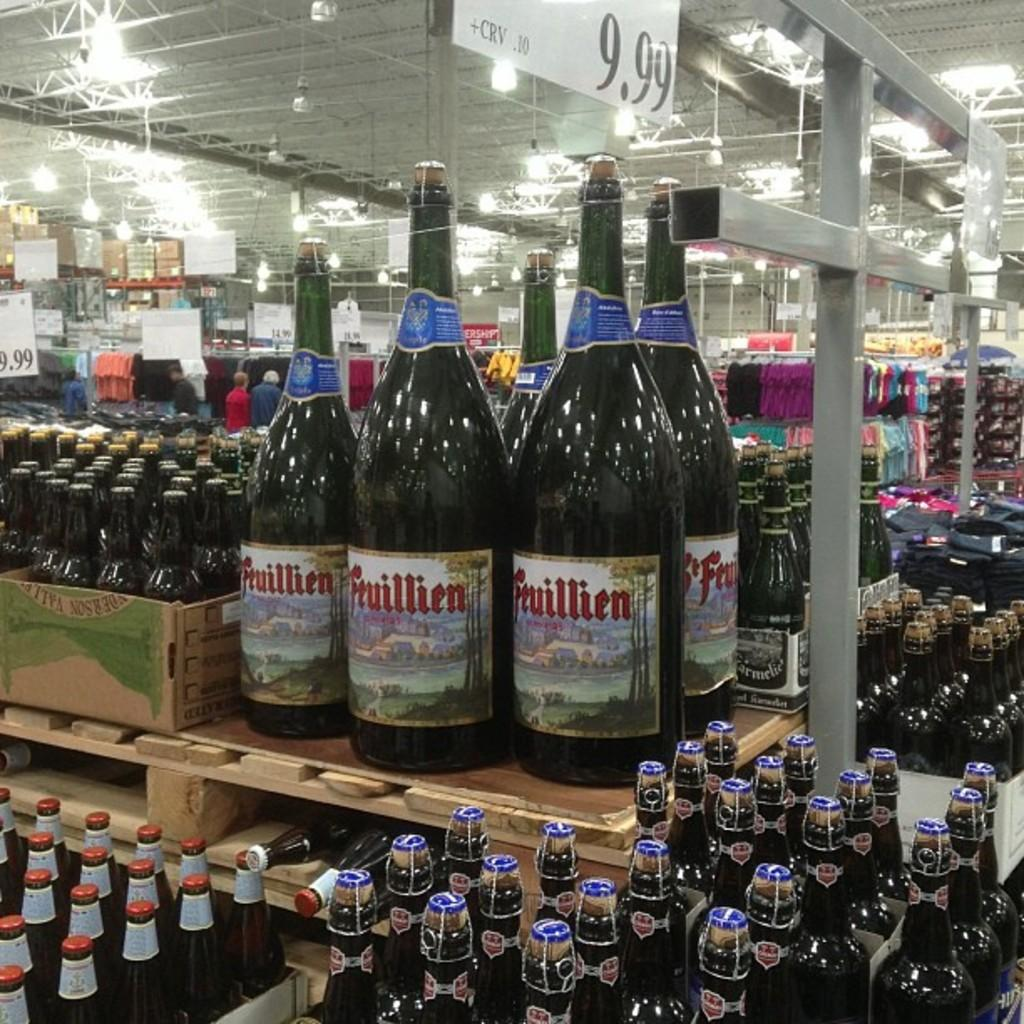What type of containers are visible in the image? There are glass bottles in the image. What type of plants can be seen growing inside the glass bottles in the image? There is no indication of plants growing inside the glass bottles in the image. 